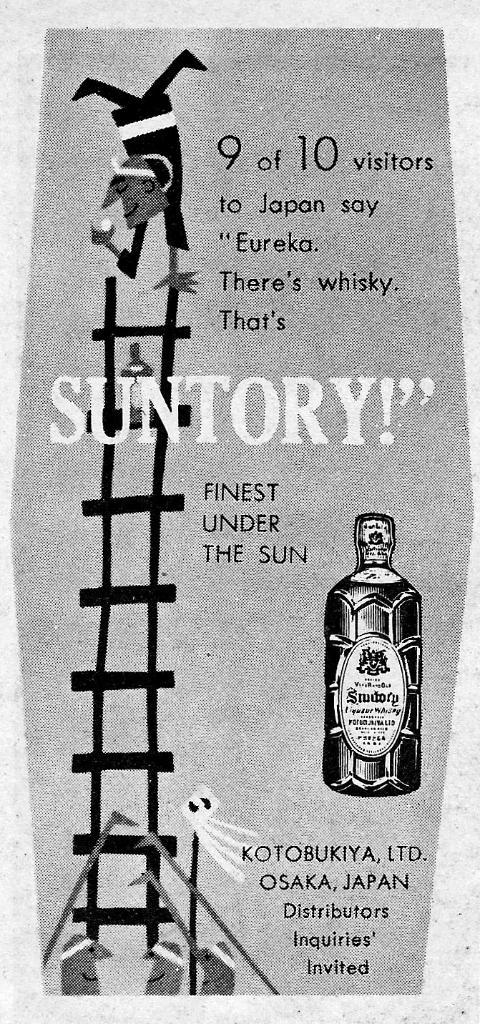<image>
Describe the image concisely. An advertisement for a Whisky made in Japan 